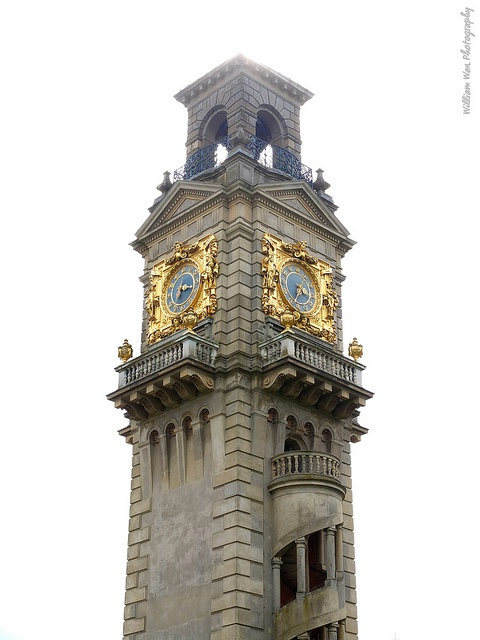Describe the objects in this image and their specific colors. I can see clock in white, darkgray, gray, and tan tones and clock in white, darkgray, gray, and tan tones in this image. 